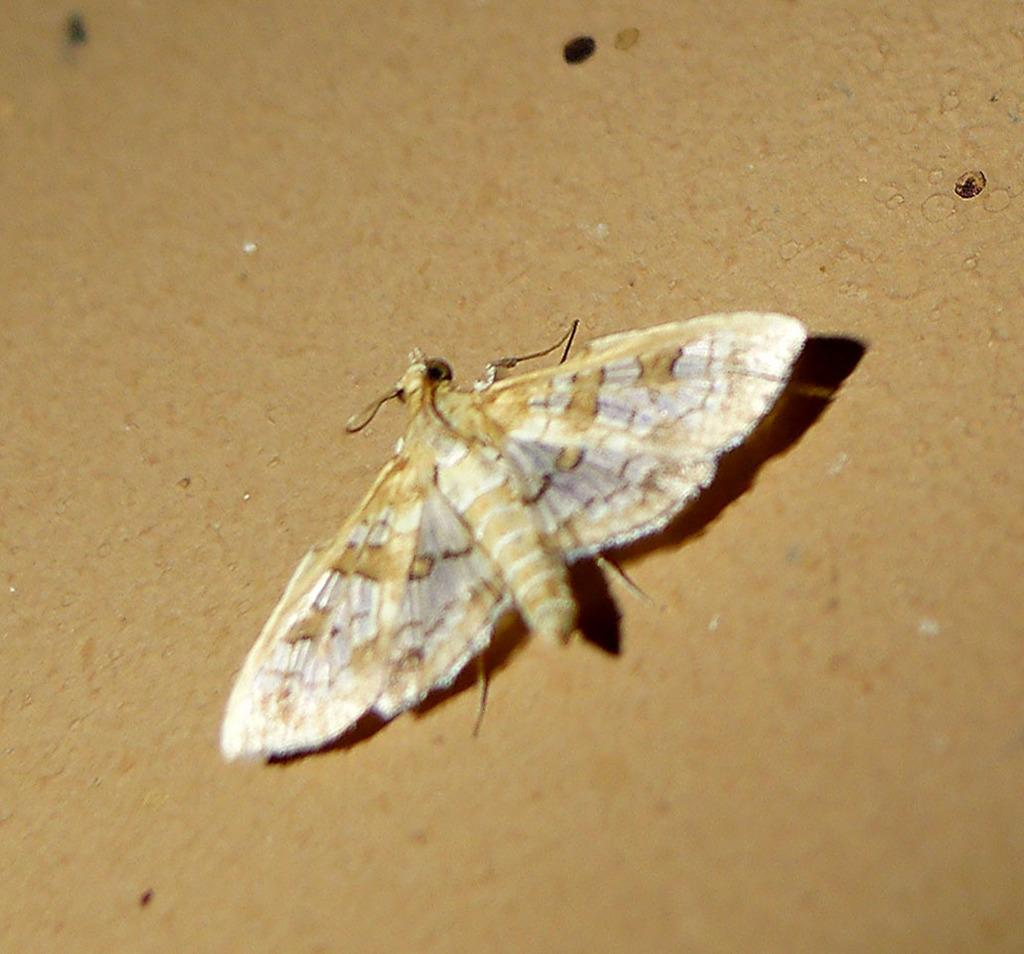What type of creature can be seen in the image? There is an insect in the image. What is the insect resting on in the image? The insect is on a brown color surface. What letters can be seen in the image? There are no letters present in the image; it only features an insect on a brown surface. 